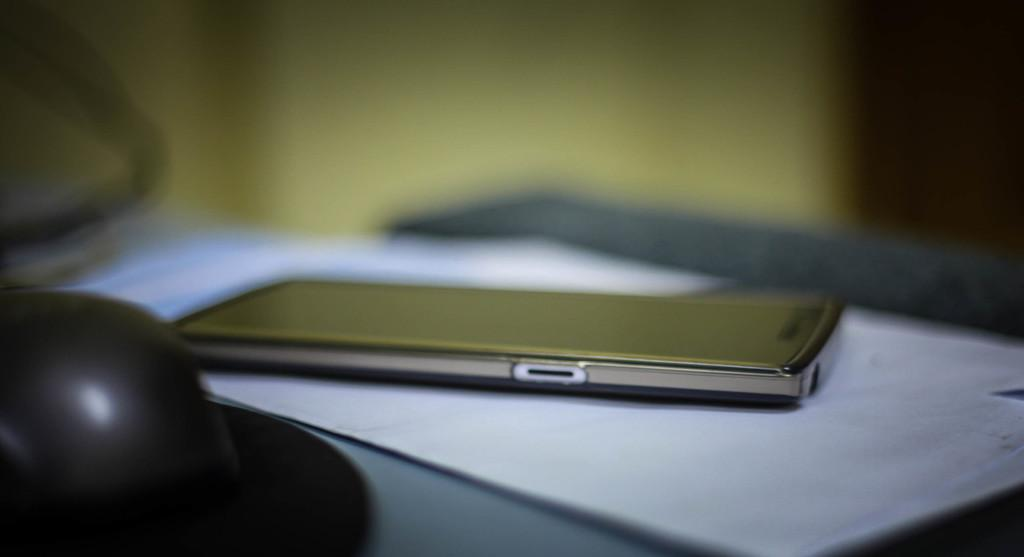What electronic device is visible in the image? There is a mobile-phone in the image. What type of paper is present in the image? There is a paper in the image. What color is the black color object in the image? The black color object in the image is black. On what surface are the objects placed in the image? The objects are on a grey color surface. How would you describe the background of the image? The background of the image is blurred. What type of cast can be seen on the person's arm in the image? There is no cast visible on a person's arm in the image; it only features a mobile-phone, paper, and a black color object on a grey surface. 